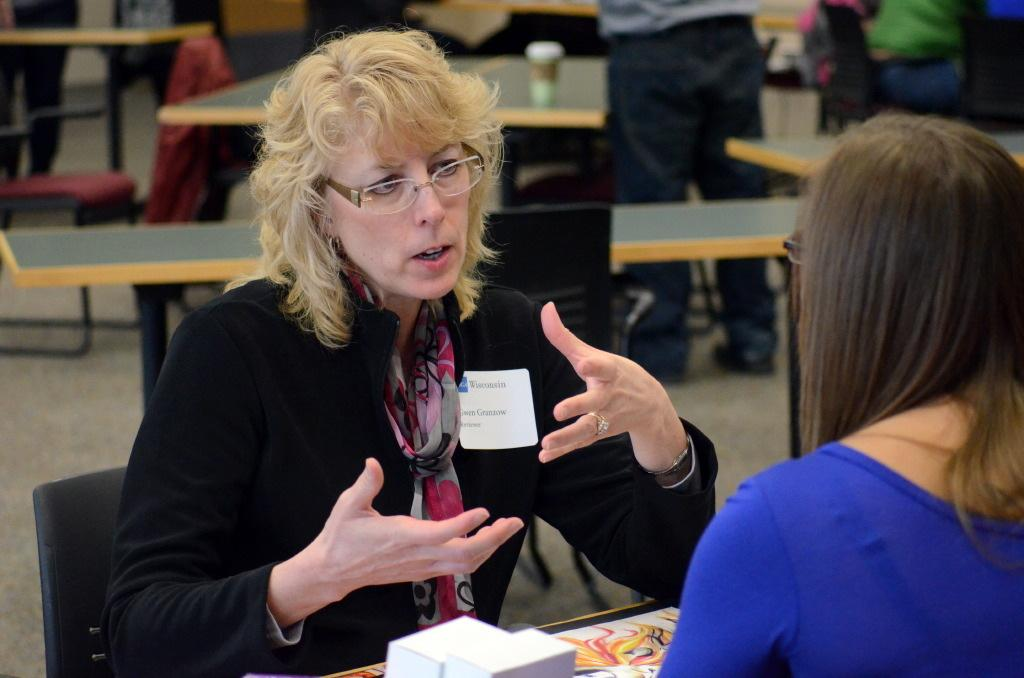How many people are in the image? There are two women in the image. What are the women doing in the image? The women are sitting around a table and looking at each other. What is the first woman doing in the image? The first woman is explaining something. Can you describe the background of the image? The background of the image is blurry. What type of discovery did the governor make in the image? There is no governor or discovery present in the image. How does the second woman care for the plants in the image? There are no plants present in the image, so it is not possible to determine how the second woman might care for them. 